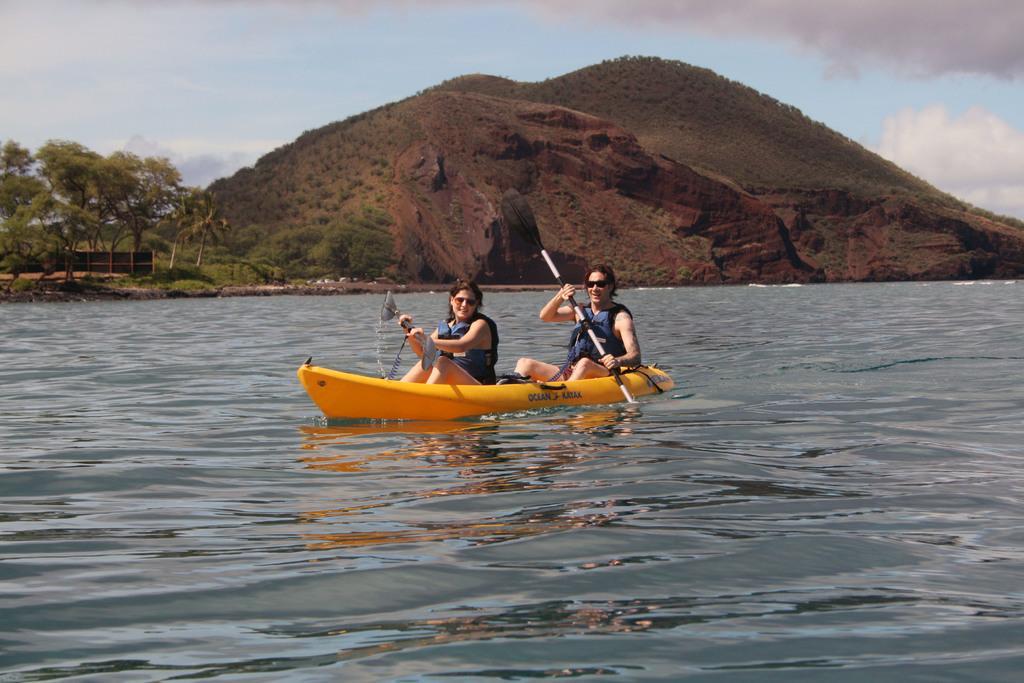Can you describe this image briefly? In this image we can see two persons sitting on kayak and rowing with paddles. And it is on water. In the back there is a hill. Also there are trees. And there is sky with clouds. 